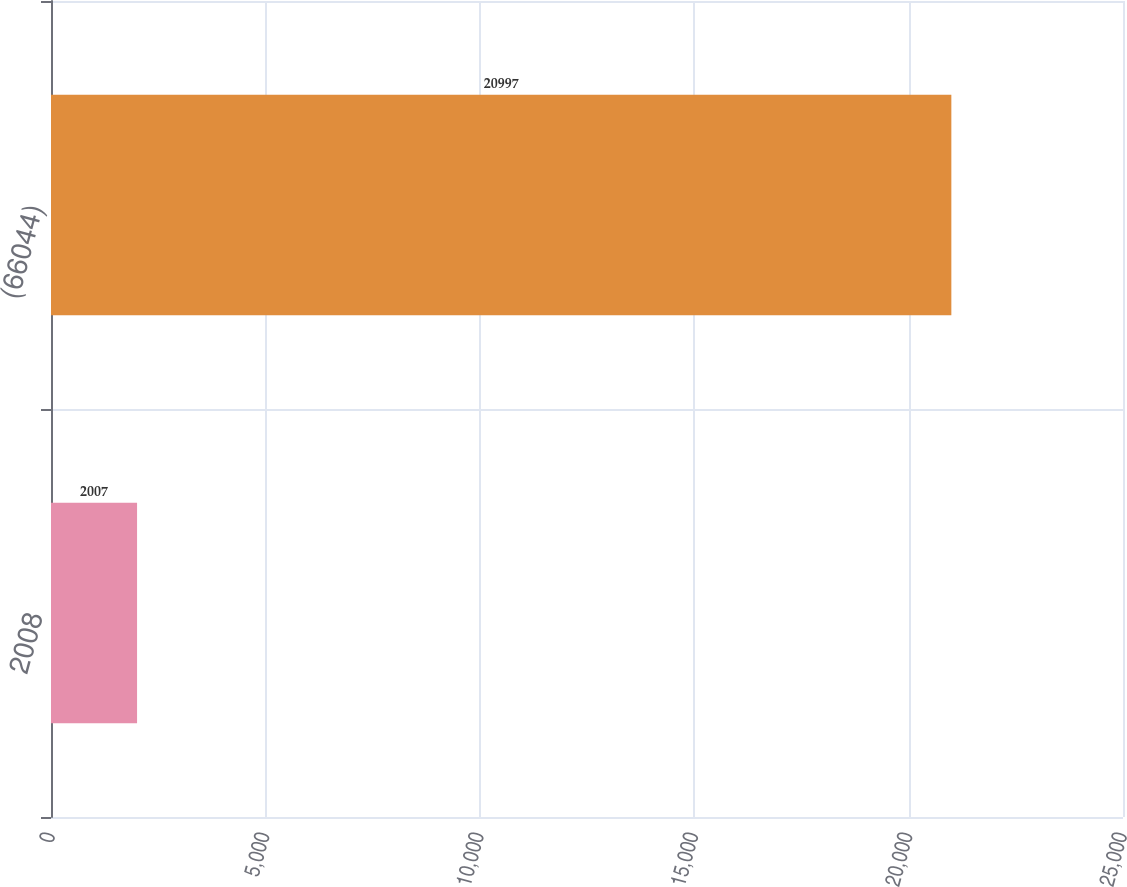Convert chart to OTSL. <chart><loc_0><loc_0><loc_500><loc_500><bar_chart><fcel>2008<fcel>(66044)<nl><fcel>2007<fcel>20997<nl></chart> 